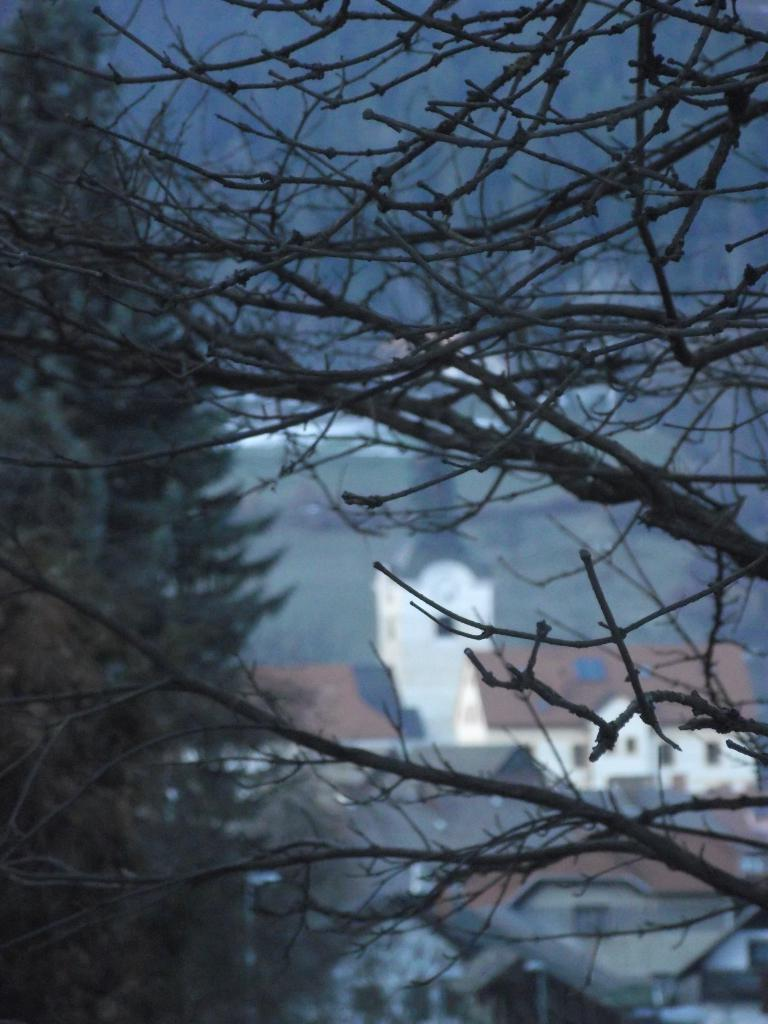What type of natural elements can be seen in the background of the image? There are trees in the background of the image. What type of man-made structures are visible in the background of the image? There are buildings in the background of the image. How would you describe the clarity of the background in the image? The background of the image is slightly blurred. How many mice can be seen running on the glass in the image? There are no mice or glass present in the image. What is the name of the downtown area visible in the image? There is no downtown area mentioned or visible in the image. 